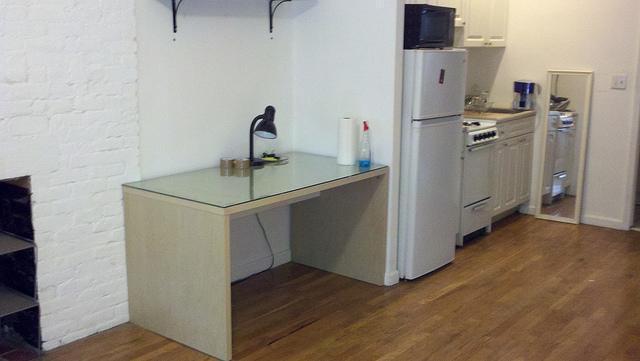What object is out of place in the kitchen?
Make your selection from the four choices given to correctly answer the question.
Options: Stove, microwave, mirror, refrigerator. Mirror. 